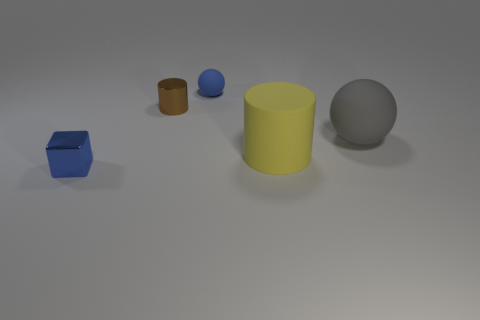The matte thing that is the same color as the small shiny block is what shape?
Provide a short and direct response. Sphere. What size is the yellow object that is the same material as the tiny sphere?
Ensure brevity in your answer.  Large. There is a tiny blue object that is on the right side of the blue thing that is on the left side of the rubber object behind the small brown metal object; what is its shape?
Your answer should be very brief. Sphere. Are there an equal number of small blue balls behind the small blue sphere and cubes?
Give a very brief answer. No. There is a thing that is the same color as the block; what is its size?
Your response must be concise. Small. Do the tiny rubber thing and the small blue shiny thing have the same shape?
Your response must be concise. No. What number of objects are spheres that are in front of the small blue matte ball or blocks?
Offer a very short reply. 2. Is the number of cubes behind the large gray matte object the same as the number of small rubber balls to the right of the large cylinder?
Your answer should be compact. Yes. How many other things are there of the same shape as the yellow matte object?
Your response must be concise. 1. Do the object in front of the rubber cylinder and the matte sphere that is to the right of the large yellow cylinder have the same size?
Provide a short and direct response. No. 